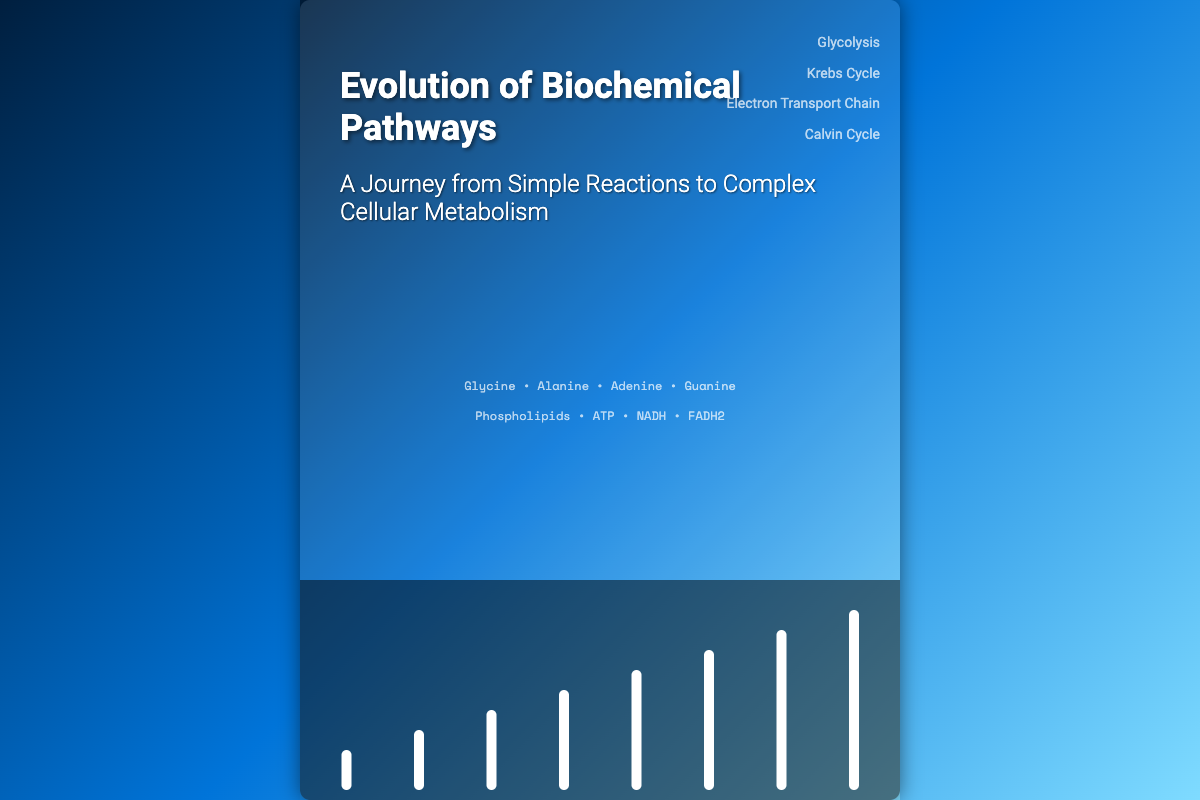What is the title of the book? The title of the book is prominently displayed at the top of the cover.
Answer: Evolution of Biochemical Pathways What is the subtitle of the book? The subtitle provides additional context about the book's content.
Answer: A Journey from Simple Reactions to Complex Cellular Metabolism Which molecules are listed on the cover? The cover features a list of specific molecules that are relevant to the book's theme.
Answer: Glycine • Alanine • Adenine • Guanine What is the first era in the timeline? The timeline outlines the historical development of biochemical pathways, starting with the earliest event.
Answer: Prebiotic Chemistry How long ago did photosynthesis begin? The timeline provides an estimate of when significant biochemical processes occurred.
Answer: ~2.7 Billion Years Ago Which biochemical pathway is associated with the final development in the timeline? The timeline culminates in the emergence of a complex biological structure involved in metabolism.
Answer: Complex Multicellularity What is the height of the era for aerobic respiration? The differing heights represent the significance or duration of each biochemical era.
Answer: 140px Which pathway is represented on the right side of the cover? Pathways relevant to cellular metabolism are highlighted for emphasis.
Answer: Glycolysis How many eras are shown in the timeline? The total number of eras illustrated reflects the progression of biochemical evolution.
Answer: 8 